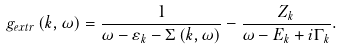<formula> <loc_0><loc_0><loc_500><loc_500>g _ { e x t r } \left ( k , \omega \right ) = \frac { 1 } { \omega - \varepsilon _ { k } - \Sigma \left ( k , \omega \right ) } - \frac { Z _ { k } } { \omega - E _ { k } + i \Gamma _ { k } } .</formula> 